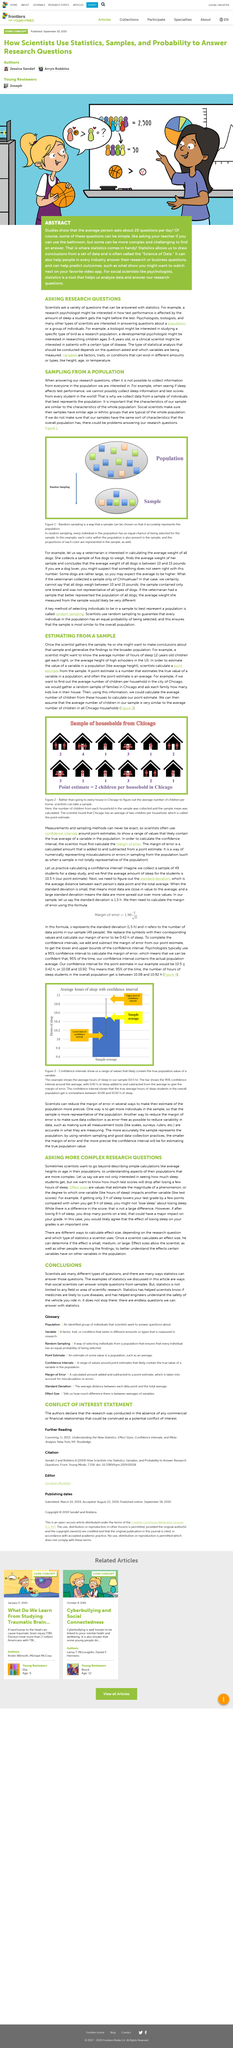Draw attention to some important aspects in this diagram. In the example, the average number of children per Chicago household is two. The homes depicted in the image represent a random sample of families, rather than being purposefully selected. Random sampling is a type of sampling in which every individual in the population has an equal chance of being selected in the sample. The confidence interval indicates that the true average hours of sleep for students in the overall population is likely to be between 10.08 and 10.92 hours. This formula uses "s" to represent the standard deviation, which is 1.5 hours. 